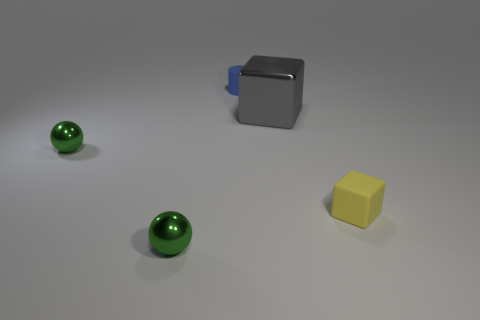What is the color of the small sphere behind the tiny metal thing in front of the yellow thing?
Provide a short and direct response. Green. How many objects are metal cubes or green shiny balls that are in front of the yellow matte object?
Ensure brevity in your answer.  2. What number of red things are tiny metallic things or metal blocks?
Ensure brevity in your answer.  0. How many other things are the same size as the yellow cube?
Keep it short and to the point. 3. How many small objects are rubber objects or gray matte cylinders?
Offer a very short reply. 2. Do the blue matte object and the block to the left of the yellow object have the same size?
Your response must be concise. No. How many other objects are there of the same shape as the small yellow thing?
Ensure brevity in your answer.  1. There is a tiny yellow object that is the same material as the tiny blue cylinder; what is its shape?
Your answer should be very brief. Cube. Is there a tiny rubber object?
Your answer should be compact. Yes. Is the number of tiny green spheres right of the tiny rubber cylinder less than the number of blocks to the right of the yellow thing?
Give a very brief answer. No. 